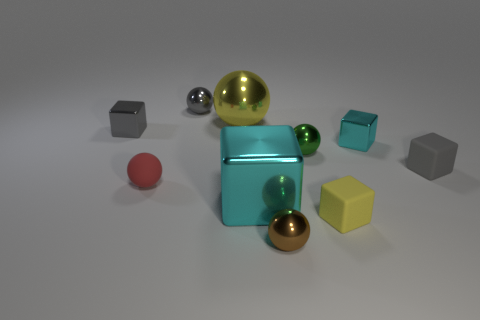How many cyan cubes must be subtracted to get 1 cyan cubes? 1 Subtract 2 balls. How many balls are left? 3 Subtract all gray metal balls. How many balls are left? 4 Subtract all yellow blocks. How many blocks are left? 4 Subtract all purple blocks. Subtract all purple spheres. How many blocks are left? 5 Add 3 yellow matte things. How many yellow matte things are left? 4 Add 3 gray metal spheres. How many gray metal spheres exist? 4 Subtract 1 gray balls. How many objects are left? 9 Subtract all brown shiny balls. Subtract all small brown balls. How many objects are left? 8 